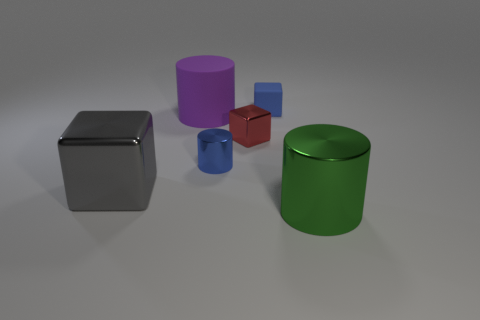Subtract all big gray metal cubes. How many cubes are left? 2 Add 1 large gray balls. How many objects exist? 7 Subtract all gray cylinders. Subtract all cyan spheres. How many cylinders are left? 3 Subtract all red cubes. Subtract all matte cylinders. How many objects are left? 4 Add 1 large purple cylinders. How many large purple cylinders are left? 2 Add 1 big shiny cylinders. How many big shiny cylinders exist? 2 Subtract 1 blue cubes. How many objects are left? 5 